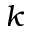Convert formula to latex. <formula><loc_0><loc_0><loc_500><loc_500>k</formula> 